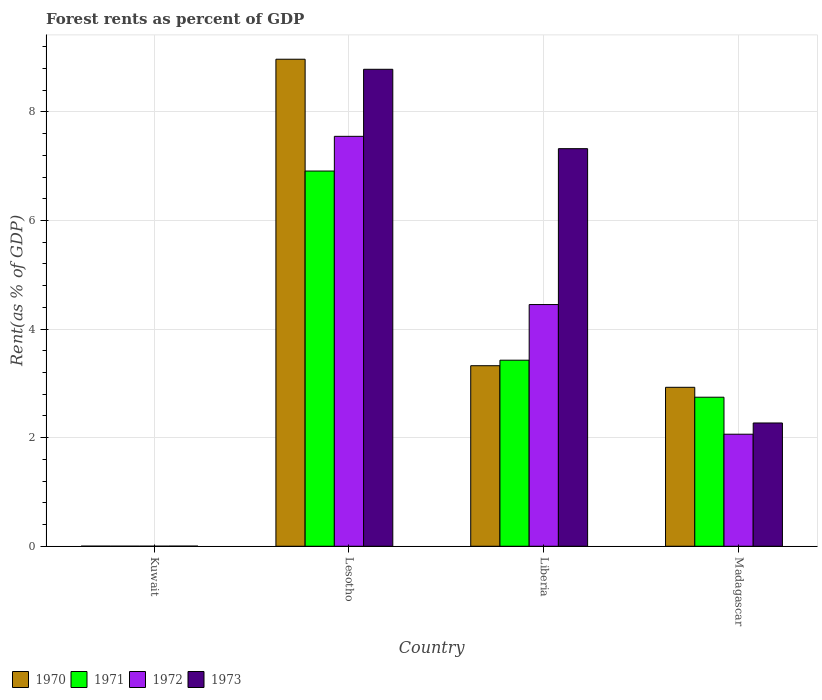How many different coloured bars are there?
Keep it short and to the point. 4. Are the number of bars on each tick of the X-axis equal?
Provide a succinct answer. Yes. How many bars are there on the 4th tick from the right?
Your answer should be very brief. 4. What is the label of the 2nd group of bars from the left?
Give a very brief answer. Lesotho. In how many cases, is the number of bars for a given country not equal to the number of legend labels?
Your response must be concise. 0. What is the forest rent in 1972 in Lesotho?
Provide a succinct answer. 7.55. Across all countries, what is the maximum forest rent in 1970?
Your answer should be very brief. 8.97. Across all countries, what is the minimum forest rent in 1971?
Give a very brief answer. 0. In which country was the forest rent in 1973 maximum?
Make the answer very short. Lesotho. In which country was the forest rent in 1973 minimum?
Offer a terse response. Kuwait. What is the total forest rent in 1971 in the graph?
Offer a very short reply. 13.08. What is the difference between the forest rent in 1970 in Lesotho and that in Liberia?
Provide a short and direct response. 5.65. What is the difference between the forest rent in 1973 in Madagascar and the forest rent in 1970 in Kuwait?
Keep it short and to the point. 2.27. What is the average forest rent in 1970 per country?
Your response must be concise. 3.81. What is the difference between the forest rent of/in 1970 and forest rent of/in 1972 in Kuwait?
Your answer should be very brief. 0. In how many countries, is the forest rent in 1970 greater than 3.2 %?
Provide a succinct answer. 2. What is the ratio of the forest rent in 1973 in Kuwait to that in Liberia?
Offer a very short reply. 0. Is the forest rent in 1972 in Lesotho less than that in Liberia?
Offer a very short reply. No. Is the difference between the forest rent in 1970 in Lesotho and Liberia greater than the difference between the forest rent in 1972 in Lesotho and Liberia?
Offer a terse response. Yes. What is the difference between the highest and the second highest forest rent in 1970?
Provide a succinct answer. 6.04. What is the difference between the highest and the lowest forest rent in 1971?
Your answer should be very brief. 6.91. Is the sum of the forest rent in 1971 in Kuwait and Lesotho greater than the maximum forest rent in 1970 across all countries?
Offer a very short reply. No. What does the 1st bar from the right in Kuwait represents?
Offer a terse response. 1973. Is it the case that in every country, the sum of the forest rent in 1972 and forest rent in 1971 is greater than the forest rent in 1973?
Provide a short and direct response. No. How many bars are there?
Offer a very short reply. 16. How many countries are there in the graph?
Offer a terse response. 4. Are the values on the major ticks of Y-axis written in scientific E-notation?
Give a very brief answer. No. Does the graph contain any zero values?
Keep it short and to the point. No. What is the title of the graph?
Make the answer very short. Forest rents as percent of GDP. Does "1977" appear as one of the legend labels in the graph?
Make the answer very short. No. What is the label or title of the Y-axis?
Provide a short and direct response. Rent(as % of GDP). What is the Rent(as % of GDP) of 1970 in Kuwait?
Offer a terse response. 0. What is the Rent(as % of GDP) in 1971 in Kuwait?
Provide a short and direct response. 0. What is the Rent(as % of GDP) in 1972 in Kuwait?
Ensure brevity in your answer.  0. What is the Rent(as % of GDP) in 1973 in Kuwait?
Provide a succinct answer. 0. What is the Rent(as % of GDP) of 1970 in Lesotho?
Ensure brevity in your answer.  8.97. What is the Rent(as % of GDP) in 1971 in Lesotho?
Offer a terse response. 6.91. What is the Rent(as % of GDP) in 1972 in Lesotho?
Provide a succinct answer. 7.55. What is the Rent(as % of GDP) of 1973 in Lesotho?
Provide a succinct answer. 8.79. What is the Rent(as % of GDP) in 1970 in Liberia?
Give a very brief answer. 3.33. What is the Rent(as % of GDP) of 1971 in Liberia?
Provide a short and direct response. 3.43. What is the Rent(as % of GDP) of 1972 in Liberia?
Offer a terse response. 4.45. What is the Rent(as % of GDP) of 1973 in Liberia?
Your response must be concise. 7.32. What is the Rent(as % of GDP) of 1970 in Madagascar?
Ensure brevity in your answer.  2.93. What is the Rent(as % of GDP) in 1971 in Madagascar?
Give a very brief answer. 2.75. What is the Rent(as % of GDP) in 1972 in Madagascar?
Your response must be concise. 2.06. What is the Rent(as % of GDP) of 1973 in Madagascar?
Provide a succinct answer. 2.27. Across all countries, what is the maximum Rent(as % of GDP) in 1970?
Give a very brief answer. 8.97. Across all countries, what is the maximum Rent(as % of GDP) in 1971?
Make the answer very short. 6.91. Across all countries, what is the maximum Rent(as % of GDP) of 1972?
Your response must be concise. 7.55. Across all countries, what is the maximum Rent(as % of GDP) in 1973?
Give a very brief answer. 8.79. Across all countries, what is the minimum Rent(as % of GDP) in 1970?
Provide a short and direct response. 0. Across all countries, what is the minimum Rent(as % of GDP) in 1971?
Provide a succinct answer. 0. Across all countries, what is the minimum Rent(as % of GDP) of 1972?
Keep it short and to the point. 0. Across all countries, what is the minimum Rent(as % of GDP) of 1973?
Offer a very short reply. 0. What is the total Rent(as % of GDP) of 1970 in the graph?
Your response must be concise. 15.23. What is the total Rent(as % of GDP) of 1971 in the graph?
Provide a succinct answer. 13.08. What is the total Rent(as % of GDP) of 1972 in the graph?
Your answer should be compact. 14.07. What is the total Rent(as % of GDP) of 1973 in the graph?
Ensure brevity in your answer.  18.38. What is the difference between the Rent(as % of GDP) in 1970 in Kuwait and that in Lesotho?
Make the answer very short. -8.97. What is the difference between the Rent(as % of GDP) of 1971 in Kuwait and that in Lesotho?
Your response must be concise. -6.91. What is the difference between the Rent(as % of GDP) in 1972 in Kuwait and that in Lesotho?
Your answer should be very brief. -7.55. What is the difference between the Rent(as % of GDP) in 1973 in Kuwait and that in Lesotho?
Ensure brevity in your answer.  -8.78. What is the difference between the Rent(as % of GDP) of 1970 in Kuwait and that in Liberia?
Provide a succinct answer. -3.32. What is the difference between the Rent(as % of GDP) of 1971 in Kuwait and that in Liberia?
Your answer should be very brief. -3.43. What is the difference between the Rent(as % of GDP) in 1972 in Kuwait and that in Liberia?
Provide a short and direct response. -4.45. What is the difference between the Rent(as % of GDP) of 1973 in Kuwait and that in Liberia?
Provide a short and direct response. -7.32. What is the difference between the Rent(as % of GDP) of 1970 in Kuwait and that in Madagascar?
Provide a succinct answer. -2.93. What is the difference between the Rent(as % of GDP) in 1971 in Kuwait and that in Madagascar?
Your answer should be compact. -2.74. What is the difference between the Rent(as % of GDP) of 1972 in Kuwait and that in Madagascar?
Give a very brief answer. -2.06. What is the difference between the Rent(as % of GDP) in 1973 in Kuwait and that in Madagascar?
Provide a succinct answer. -2.27. What is the difference between the Rent(as % of GDP) of 1970 in Lesotho and that in Liberia?
Ensure brevity in your answer.  5.65. What is the difference between the Rent(as % of GDP) of 1971 in Lesotho and that in Liberia?
Provide a short and direct response. 3.48. What is the difference between the Rent(as % of GDP) in 1972 in Lesotho and that in Liberia?
Your answer should be compact. 3.1. What is the difference between the Rent(as % of GDP) in 1973 in Lesotho and that in Liberia?
Your answer should be compact. 1.46. What is the difference between the Rent(as % of GDP) of 1970 in Lesotho and that in Madagascar?
Give a very brief answer. 6.04. What is the difference between the Rent(as % of GDP) in 1971 in Lesotho and that in Madagascar?
Give a very brief answer. 4.17. What is the difference between the Rent(as % of GDP) of 1972 in Lesotho and that in Madagascar?
Offer a very short reply. 5.49. What is the difference between the Rent(as % of GDP) of 1973 in Lesotho and that in Madagascar?
Your answer should be compact. 6.51. What is the difference between the Rent(as % of GDP) in 1970 in Liberia and that in Madagascar?
Offer a very short reply. 0.4. What is the difference between the Rent(as % of GDP) in 1971 in Liberia and that in Madagascar?
Your response must be concise. 0.68. What is the difference between the Rent(as % of GDP) of 1972 in Liberia and that in Madagascar?
Your answer should be compact. 2.39. What is the difference between the Rent(as % of GDP) of 1973 in Liberia and that in Madagascar?
Ensure brevity in your answer.  5.05. What is the difference between the Rent(as % of GDP) of 1970 in Kuwait and the Rent(as % of GDP) of 1971 in Lesotho?
Your answer should be compact. -6.91. What is the difference between the Rent(as % of GDP) in 1970 in Kuwait and the Rent(as % of GDP) in 1972 in Lesotho?
Make the answer very short. -7.55. What is the difference between the Rent(as % of GDP) in 1970 in Kuwait and the Rent(as % of GDP) in 1973 in Lesotho?
Give a very brief answer. -8.78. What is the difference between the Rent(as % of GDP) in 1971 in Kuwait and the Rent(as % of GDP) in 1972 in Lesotho?
Keep it short and to the point. -7.55. What is the difference between the Rent(as % of GDP) of 1971 in Kuwait and the Rent(as % of GDP) of 1973 in Lesotho?
Your response must be concise. -8.78. What is the difference between the Rent(as % of GDP) in 1972 in Kuwait and the Rent(as % of GDP) in 1973 in Lesotho?
Give a very brief answer. -8.78. What is the difference between the Rent(as % of GDP) of 1970 in Kuwait and the Rent(as % of GDP) of 1971 in Liberia?
Keep it short and to the point. -3.43. What is the difference between the Rent(as % of GDP) of 1970 in Kuwait and the Rent(as % of GDP) of 1972 in Liberia?
Provide a short and direct response. -4.45. What is the difference between the Rent(as % of GDP) in 1970 in Kuwait and the Rent(as % of GDP) in 1973 in Liberia?
Offer a terse response. -7.32. What is the difference between the Rent(as % of GDP) in 1971 in Kuwait and the Rent(as % of GDP) in 1972 in Liberia?
Your answer should be compact. -4.45. What is the difference between the Rent(as % of GDP) of 1971 in Kuwait and the Rent(as % of GDP) of 1973 in Liberia?
Your answer should be very brief. -7.32. What is the difference between the Rent(as % of GDP) of 1972 in Kuwait and the Rent(as % of GDP) of 1973 in Liberia?
Offer a terse response. -7.32. What is the difference between the Rent(as % of GDP) in 1970 in Kuwait and the Rent(as % of GDP) in 1971 in Madagascar?
Ensure brevity in your answer.  -2.74. What is the difference between the Rent(as % of GDP) in 1970 in Kuwait and the Rent(as % of GDP) in 1972 in Madagascar?
Provide a short and direct response. -2.06. What is the difference between the Rent(as % of GDP) of 1970 in Kuwait and the Rent(as % of GDP) of 1973 in Madagascar?
Offer a very short reply. -2.27. What is the difference between the Rent(as % of GDP) in 1971 in Kuwait and the Rent(as % of GDP) in 1972 in Madagascar?
Offer a very short reply. -2.06. What is the difference between the Rent(as % of GDP) of 1971 in Kuwait and the Rent(as % of GDP) of 1973 in Madagascar?
Your answer should be compact. -2.27. What is the difference between the Rent(as % of GDP) of 1972 in Kuwait and the Rent(as % of GDP) of 1973 in Madagascar?
Offer a very short reply. -2.27. What is the difference between the Rent(as % of GDP) in 1970 in Lesotho and the Rent(as % of GDP) in 1971 in Liberia?
Give a very brief answer. 5.54. What is the difference between the Rent(as % of GDP) of 1970 in Lesotho and the Rent(as % of GDP) of 1972 in Liberia?
Your response must be concise. 4.52. What is the difference between the Rent(as % of GDP) of 1970 in Lesotho and the Rent(as % of GDP) of 1973 in Liberia?
Provide a short and direct response. 1.65. What is the difference between the Rent(as % of GDP) of 1971 in Lesotho and the Rent(as % of GDP) of 1972 in Liberia?
Ensure brevity in your answer.  2.46. What is the difference between the Rent(as % of GDP) of 1971 in Lesotho and the Rent(as % of GDP) of 1973 in Liberia?
Provide a succinct answer. -0.41. What is the difference between the Rent(as % of GDP) of 1972 in Lesotho and the Rent(as % of GDP) of 1973 in Liberia?
Provide a succinct answer. 0.23. What is the difference between the Rent(as % of GDP) in 1970 in Lesotho and the Rent(as % of GDP) in 1971 in Madagascar?
Provide a short and direct response. 6.23. What is the difference between the Rent(as % of GDP) of 1970 in Lesotho and the Rent(as % of GDP) of 1972 in Madagascar?
Provide a succinct answer. 6.91. What is the difference between the Rent(as % of GDP) in 1971 in Lesotho and the Rent(as % of GDP) in 1972 in Madagascar?
Make the answer very short. 4.85. What is the difference between the Rent(as % of GDP) of 1971 in Lesotho and the Rent(as % of GDP) of 1973 in Madagascar?
Your response must be concise. 4.64. What is the difference between the Rent(as % of GDP) in 1972 in Lesotho and the Rent(as % of GDP) in 1973 in Madagascar?
Your response must be concise. 5.28. What is the difference between the Rent(as % of GDP) of 1970 in Liberia and the Rent(as % of GDP) of 1971 in Madagascar?
Ensure brevity in your answer.  0.58. What is the difference between the Rent(as % of GDP) of 1970 in Liberia and the Rent(as % of GDP) of 1972 in Madagascar?
Your answer should be compact. 1.26. What is the difference between the Rent(as % of GDP) of 1970 in Liberia and the Rent(as % of GDP) of 1973 in Madagascar?
Your answer should be compact. 1.05. What is the difference between the Rent(as % of GDP) of 1971 in Liberia and the Rent(as % of GDP) of 1972 in Madagascar?
Your response must be concise. 1.36. What is the difference between the Rent(as % of GDP) in 1971 in Liberia and the Rent(as % of GDP) in 1973 in Madagascar?
Make the answer very short. 1.16. What is the difference between the Rent(as % of GDP) of 1972 in Liberia and the Rent(as % of GDP) of 1973 in Madagascar?
Your answer should be compact. 2.18. What is the average Rent(as % of GDP) of 1970 per country?
Your response must be concise. 3.81. What is the average Rent(as % of GDP) of 1971 per country?
Offer a terse response. 3.27. What is the average Rent(as % of GDP) in 1972 per country?
Your response must be concise. 3.52. What is the average Rent(as % of GDP) of 1973 per country?
Keep it short and to the point. 4.6. What is the difference between the Rent(as % of GDP) in 1970 and Rent(as % of GDP) in 1971 in Kuwait?
Provide a succinct answer. 0. What is the difference between the Rent(as % of GDP) of 1970 and Rent(as % of GDP) of 1972 in Kuwait?
Your answer should be very brief. 0. What is the difference between the Rent(as % of GDP) of 1970 and Rent(as % of GDP) of 1973 in Kuwait?
Offer a very short reply. -0. What is the difference between the Rent(as % of GDP) in 1971 and Rent(as % of GDP) in 1972 in Kuwait?
Your answer should be very brief. -0. What is the difference between the Rent(as % of GDP) in 1971 and Rent(as % of GDP) in 1973 in Kuwait?
Keep it short and to the point. -0. What is the difference between the Rent(as % of GDP) in 1972 and Rent(as % of GDP) in 1973 in Kuwait?
Provide a succinct answer. -0. What is the difference between the Rent(as % of GDP) in 1970 and Rent(as % of GDP) in 1971 in Lesotho?
Provide a succinct answer. 2.06. What is the difference between the Rent(as % of GDP) of 1970 and Rent(as % of GDP) of 1972 in Lesotho?
Give a very brief answer. 1.42. What is the difference between the Rent(as % of GDP) in 1970 and Rent(as % of GDP) in 1973 in Lesotho?
Keep it short and to the point. 0.19. What is the difference between the Rent(as % of GDP) in 1971 and Rent(as % of GDP) in 1972 in Lesotho?
Ensure brevity in your answer.  -0.64. What is the difference between the Rent(as % of GDP) in 1971 and Rent(as % of GDP) in 1973 in Lesotho?
Your response must be concise. -1.87. What is the difference between the Rent(as % of GDP) in 1972 and Rent(as % of GDP) in 1973 in Lesotho?
Provide a succinct answer. -1.24. What is the difference between the Rent(as % of GDP) in 1970 and Rent(as % of GDP) in 1971 in Liberia?
Keep it short and to the point. -0.1. What is the difference between the Rent(as % of GDP) of 1970 and Rent(as % of GDP) of 1972 in Liberia?
Provide a succinct answer. -1.13. What is the difference between the Rent(as % of GDP) of 1970 and Rent(as % of GDP) of 1973 in Liberia?
Provide a short and direct response. -4. What is the difference between the Rent(as % of GDP) of 1971 and Rent(as % of GDP) of 1972 in Liberia?
Your response must be concise. -1.02. What is the difference between the Rent(as % of GDP) in 1971 and Rent(as % of GDP) in 1973 in Liberia?
Your answer should be compact. -3.9. What is the difference between the Rent(as % of GDP) of 1972 and Rent(as % of GDP) of 1973 in Liberia?
Make the answer very short. -2.87. What is the difference between the Rent(as % of GDP) in 1970 and Rent(as % of GDP) in 1971 in Madagascar?
Ensure brevity in your answer.  0.18. What is the difference between the Rent(as % of GDP) in 1970 and Rent(as % of GDP) in 1972 in Madagascar?
Offer a terse response. 0.86. What is the difference between the Rent(as % of GDP) of 1970 and Rent(as % of GDP) of 1973 in Madagascar?
Offer a terse response. 0.66. What is the difference between the Rent(as % of GDP) of 1971 and Rent(as % of GDP) of 1972 in Madagascar?
Ensure brevity in your answer.  0.68. What is the difference between the Rent(as % of GDP) in 1971 and Rent(as % of GDP) in 1973 in Madagascar?
Your answer should be compact. 0.47. What is the difference between the Rent(as % of GDP) in 1972 and Rent(as % of GDP) in 1973 in Madagascar?
Your response must be concise. -0.21. What is the ratio of the Rent(as % of GDP) in 1971 in Kuwait to that in Liberia?
Provide a succinct answer. 0. What is the ratio of the Rent(as % of GDP) in 1970 in Kuwait to that in Madagascar?
Your answer should be compact. 0. What is the ratio of the Rent(as % of GDP) of 1973 in Kuwait to that in Madagascar?
Your answer should be compact. 0. What is the ratio of the Rent(as % of GDP) of 1970 in Lesotho to that in Liberia?
Ensure brevity in your answer.  2.7. What is the ratio of the Rent(as % of GDP) of 1971 in Lesotho to that in Liberia?
Make the answer very short. 2.02. What is the ratio of the Rent(as % of GDP) in 1972 in Lesotho to that in Liberia?
Make the answer very short. 1.7. What is the ratio of the Rent(as % of GDP) in 1973 in Lesotho to that in Liberia?
Ensure brevity in your answer.  1.2. What is the ratio of the Rent(as % of GDP) of 1970 in Lesotho to that in Madagascar?
Your answer should be compact. 3.06. What is the ratio of the Rent(as % of GDP) in 1971 in Lesotho to that in Madagascar?
Offer a terse response. 2.52. What is the ratio of the Rent(as % of GDP) in 1972 in Lesotho to that in Madagascar?
Your answer should be very brief. 3.66. What is the ratio of the Rent(as % of GDP) of 1973 in Lesotho to that in Madagascar?
Ensure brevity in your answer.  3.87. What is the ratio of the Rent(as % of GDP) of 1970 in Liberia to that in Madagascar?
Keep it short and to the point. 1.14. What is the ratio of the Rent(as % of GDP) of 1971 in Liberia to that in Madagascar?
Give a very brief answer. 1.25. What is the ratio of the Rent(as % of GDP) of 1972 in Liberia to that in Madagascar?
Keep it short and to the point. 2.16. What is the ratio of the Rent(as % of GDP) of 1973 in Liberia to that in Madagascar?
Your answer should be compact. 3.23. What is the difference between the highest and the second highest Rent(as % of GDP) of 1970?
Your answer should be compact. 5.65. What is the difference between the highest and the second highest Rent(as % of GDP) of 1971?
Ensure brevity in your answer.  3.48. What is the difference between the highest and the second highest Rent(as % of GDP) in 1972?
Make the answer very short. 3.1. What is the difference between the highest and the second highest Rent(as % of GDP) in 1973?
Your response must be concise. 1.46. What is the difference between the highest and the lowest Rent(as % of GDP) in 1970?
Your answer should be very brief. 8.97. What is the difference between the highest and the lowest Rent(as % of GDP) of 1971?
Offer a very short reply. 6.91. What is the difference between the highest and the lowest Rent(as % of GDP) of 1972?
Keep it short and to the point. 7.55. What is the difference between the highest and the lowest Rent(as % of GDP) of 1973?
Your response must be concise. 8.78. 